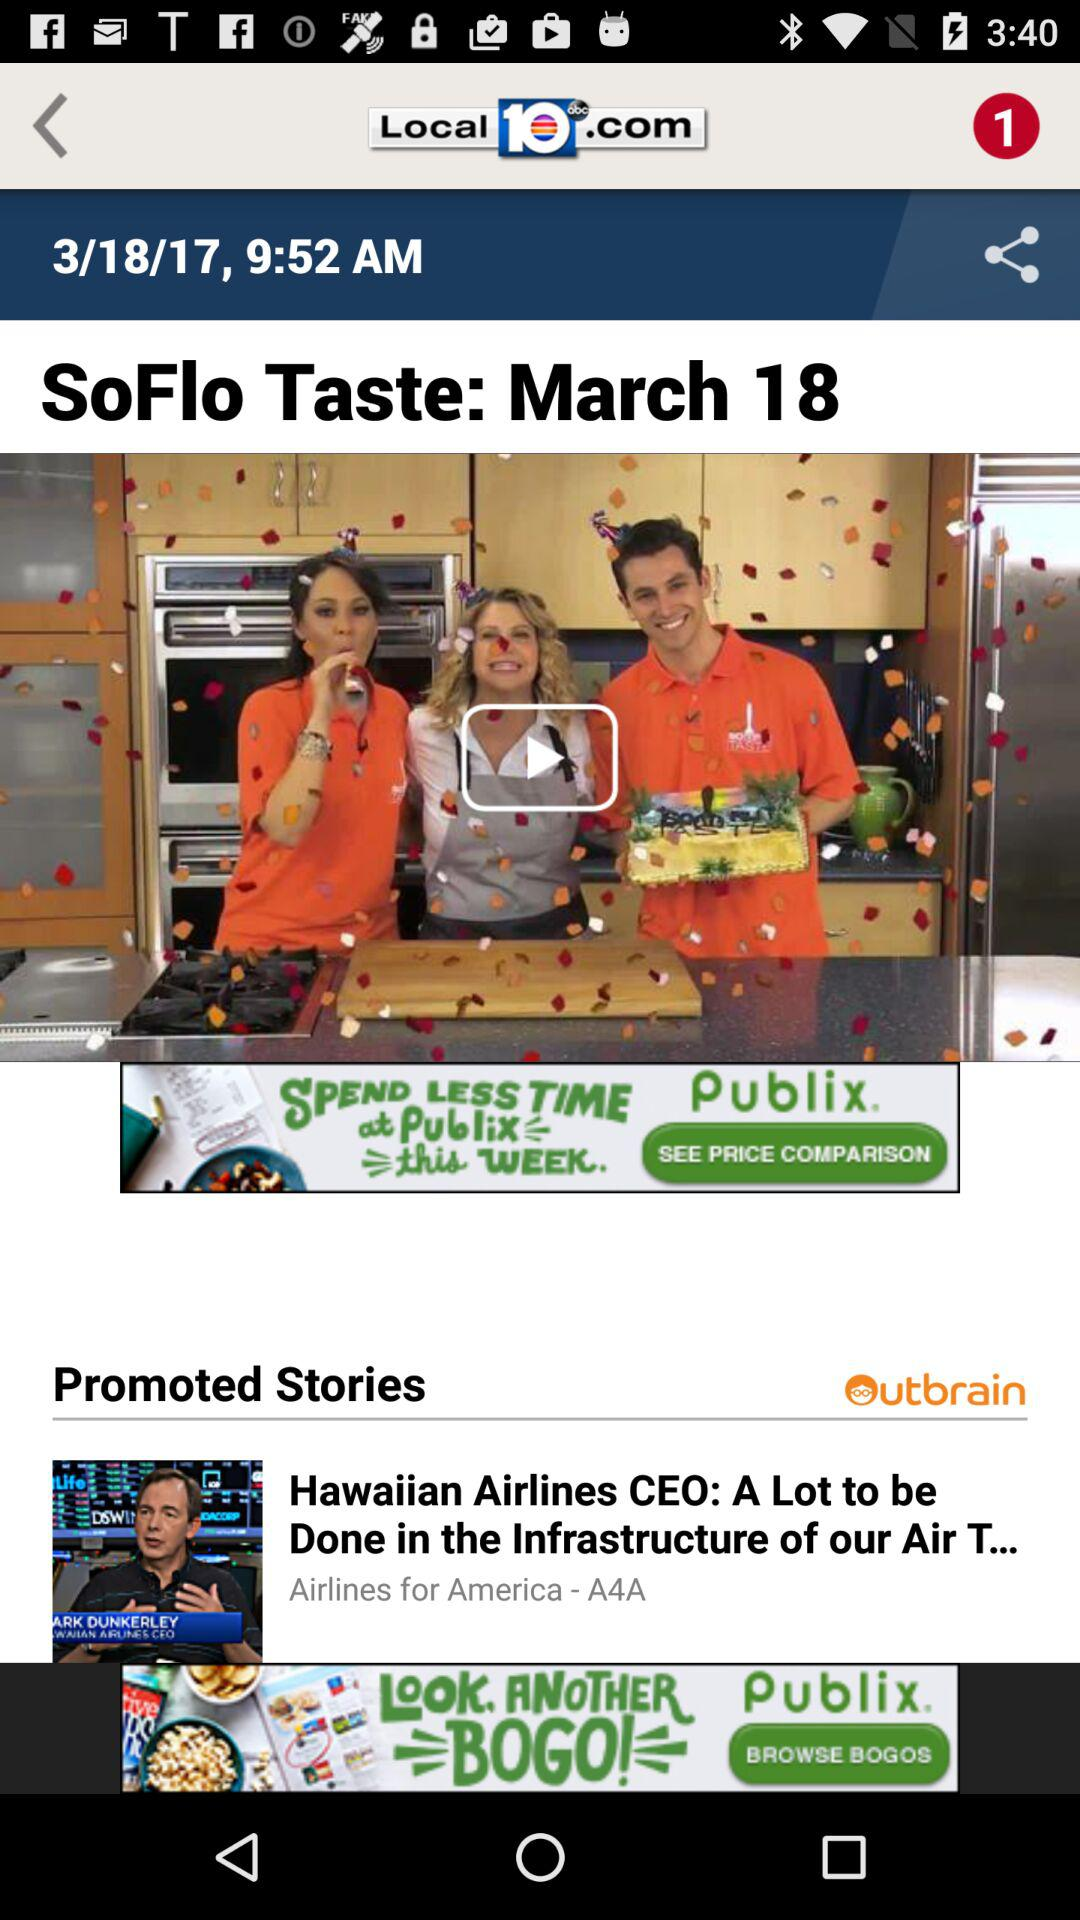What is the date? The date is March 18, 2017. 